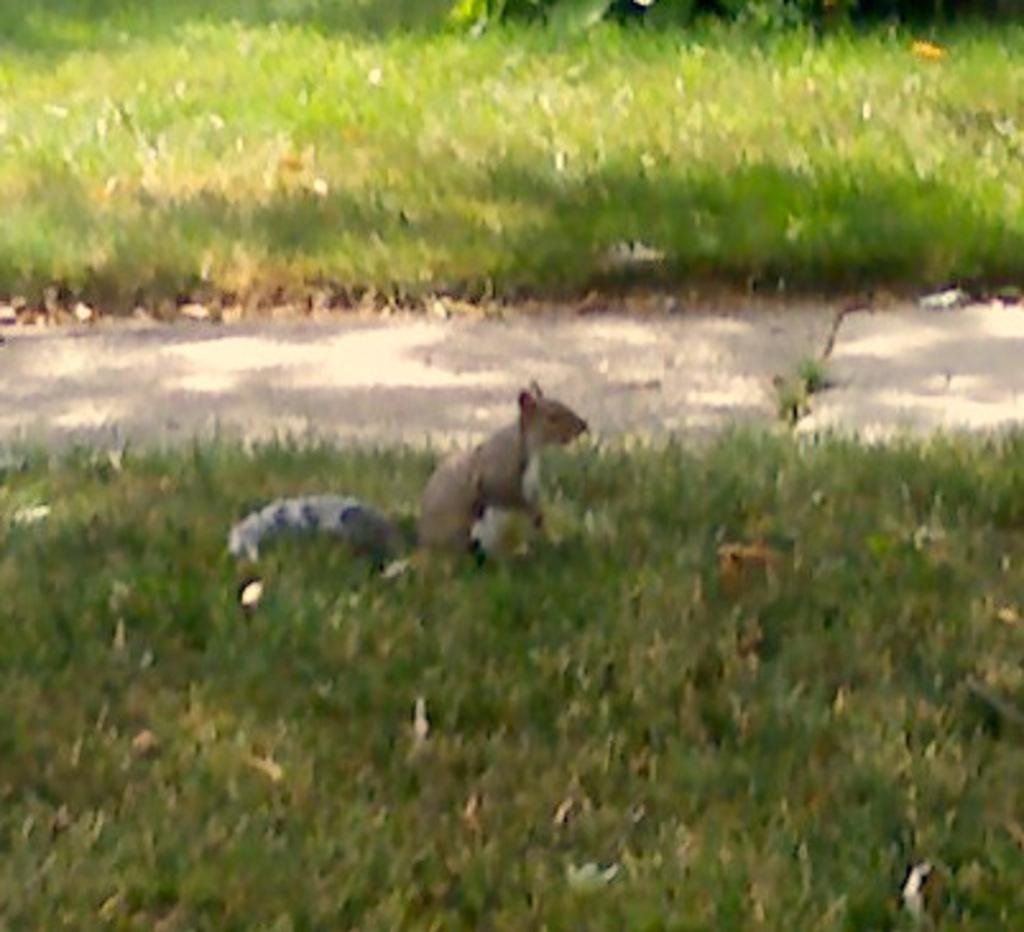What animal is in the center of the image? There is a squirrel in the center of the image. What type of vegetation is present in the image? There is grass in the image. What can be seen in the background of the image? There is a walkway in the background of the image. What type of jar is the squirrel holding in the image? There is no jar present in the image; the squirrel is not holding anything. 